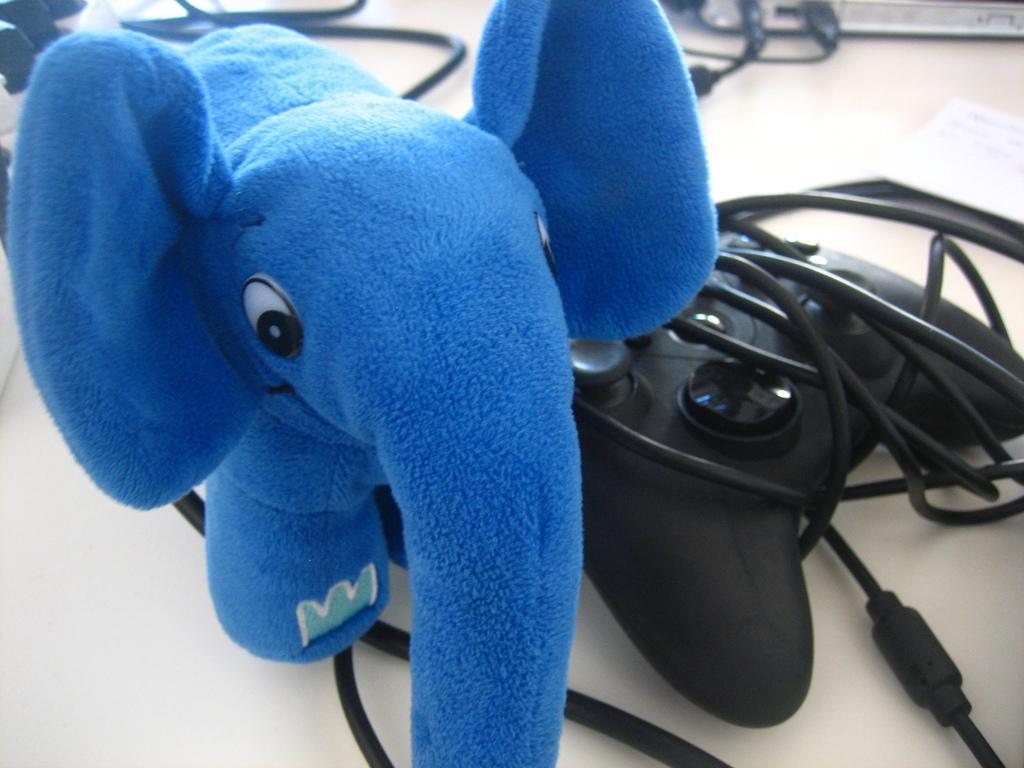Describe this image in one or two sentences. In the center of this picture we can see the toy elephant and we can see the joystick, cables and some other items seems to be placed on the top of the table. 